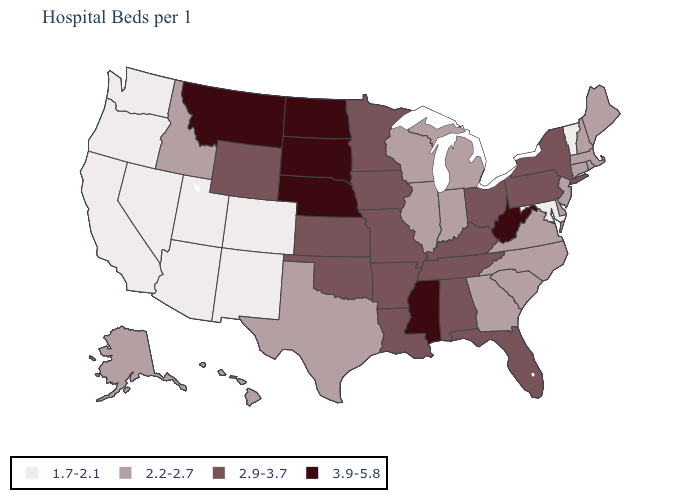What is the value of Washington?
Keep it brief. 1.7-2.1. What is the lowest value in the West?
Quick response, please. 1.7-2.1. Name the states that have a value in the range 2.9-3.7?
Concise answer only. Alabama, Arkansas, Florida, Iowa, Kansas, Kentucky, Louisiana, Minnesota, Missouri, New York, Ohio, Oklahoma, Pennsylvania, Tennessee, Wyoming. Does Arizona have the same value as Colorado?
Concise answer only. Yes. Name the states that have a value in the range 2.9-3.7?
Concise answer only. Alabama, Arkansas, Florida, Iowa, Kansas, Kentucky, Louisiana, Minnesota, Missouri, New York, Ohio, Oklahoma, Pennsylvania, Tennessee, Wyoming. Name the states that have a value in the range 1.7-2.1?
Keep it brief. Arizona, California, Colorado, Maryland, Nevada, New Mexico, Oregon, Utah, Vermont, Washington. What is the value of Missouri?
Answer briefly. 2.9-3.7. Does Oklahoma have a higher value than Iowa?
Keep it brief. No. What is the value of Florida?
Give a very brief answer. 2.9-3.7. Name the states that have a value in the range 1.7-2.1?
Answer briefly. Arizona, California, Colorado, Maryland, Nevada, New Mexico, Oregon, Utah, Vermont, Washington. Name the states that have a value in the range 3.9-5.8?
Be succinct. Mississippi, Montana, Nebraska, North Dakota, South Dakota, West Virginia. What is the value of New York?
Short answer required. 2.9-3.7. Among the states that border Montana , which have the lowest value?
Short answer required. Idaho. What is the highest value in the USA?
Give a very brief answer. 3.9-5.8. What is the value of Rhode Island?
Concise answer only. 2.2-2.7. 